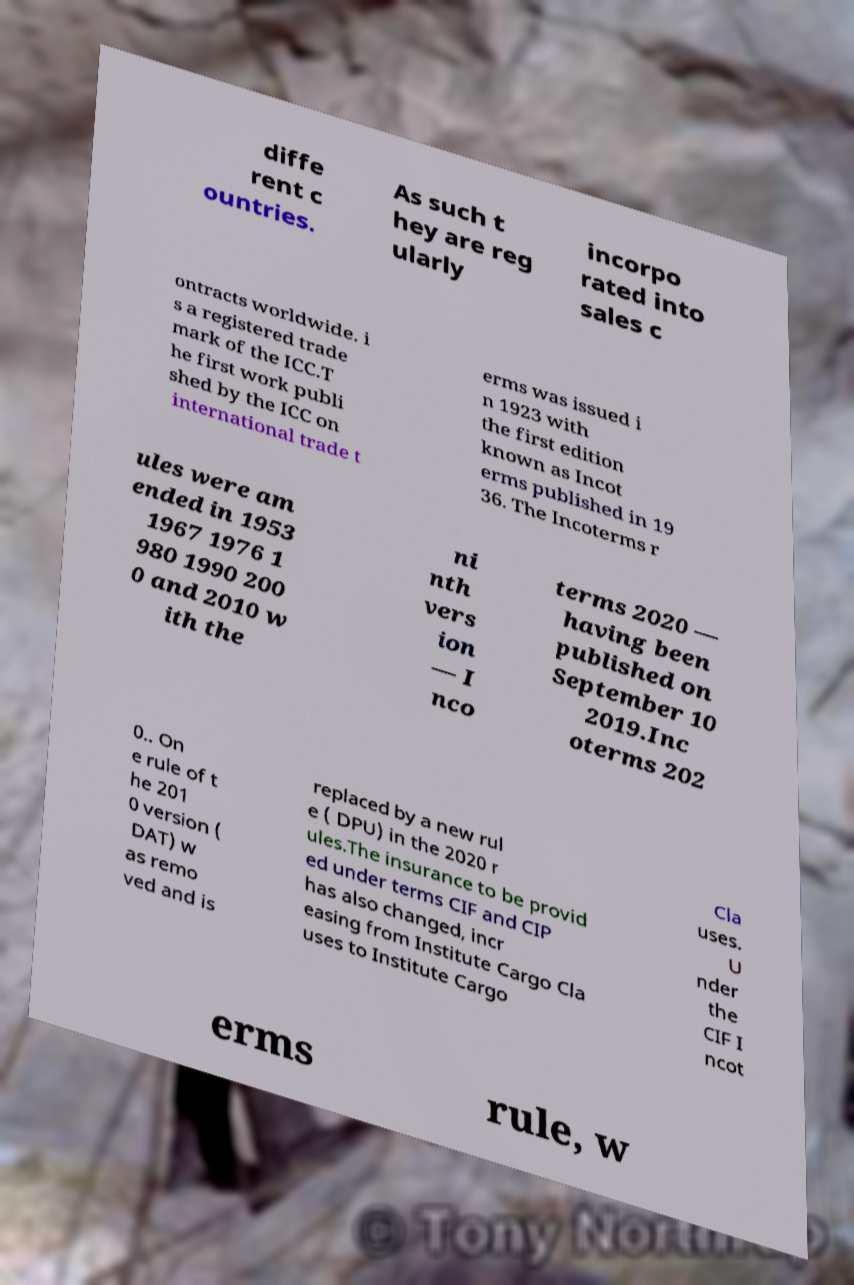Can you read and provide the text displayed in the image?This photo seems to have some interesting text. Can you extract and type it out for me? diffe rent c ountries. As such t hey are reg ularly incorpo rated into sales c ontracts worldwide. i s a registered trade mark of the ICC.T he first work publi shed by the ICC on international trade t erms was issued i n 1923 with the first edition known as Incot erms published in 19 36. The Incoterms r ules were am ended in 1953 1967 1976 1 980 1990 200 0 and 2010 w ith the ni nth vers ion — I nco terms 2020 — having been published on September 10 2019.Inc oterms 202 0.. On e rule of t he 201 0 version ( DAT) w as remo ved and is replaced by a new rul e ( DPU) in the 2020 r ules.The insurance to be provid ed under terms CIF and CIP has also changed, incr easing from Institute Cargo Cla uses to Institute Cargo Cla uses. U nder the CIF I ncot erms rule, w 